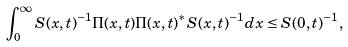Convert formula to latex. <formula><loc_0><loc_0><loc_500><loc_500>\int _ { 0 } ^ { \infty } S ( x , t ) ^ { - 1 } \Pi ( x , t ) \Pi ( x , t ) ^ { * } S ( x , t ) ^ { - 1 } d x \leq S ( 0 , t ) ^ { - 1 } ,</formula> 